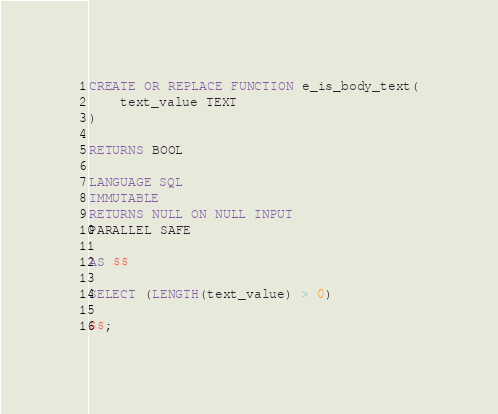Convert code to text. <code><loc_0><loc_0><loc_500><loc_500><_SQL_>CREATE OR REPLACE FUNCTION e_is_body_text(
    text_value TEXT
)

RETURNS BOOL

LANGUAGE SQL
IMMUTABLE
RETURNS NULL ON NULL INPUT
PARALLEL SAFE

AS $$

SELECT (LENGTH(text_value) > 0)

$$;
</code> 